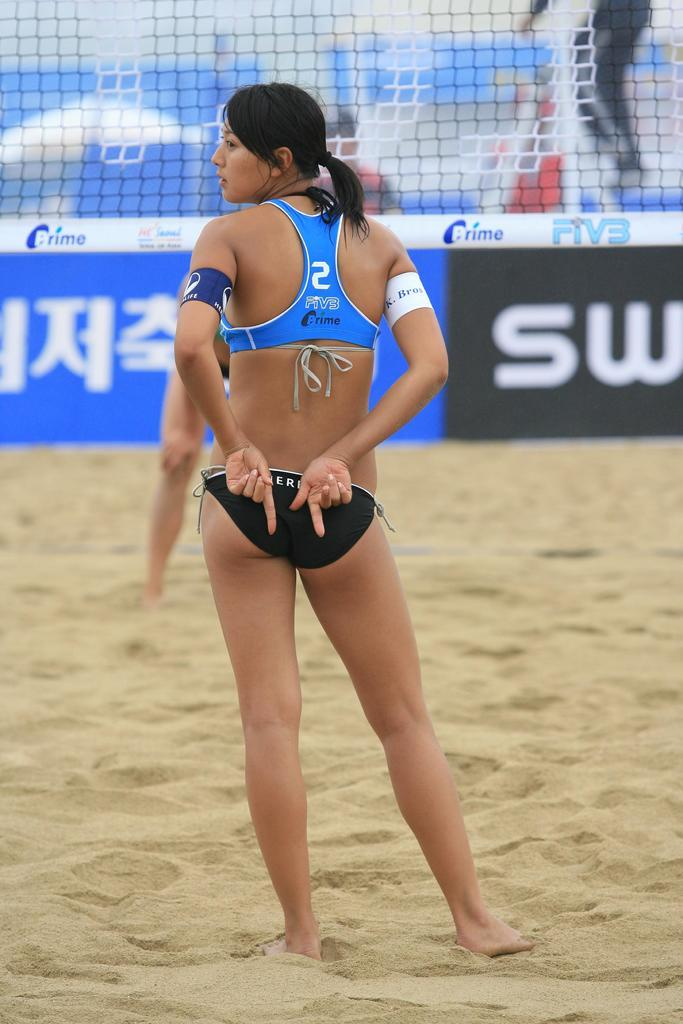<image>
Render a clear and concise summary of the photo. beach volleyball with player #2 giving a hand signal behind her back 